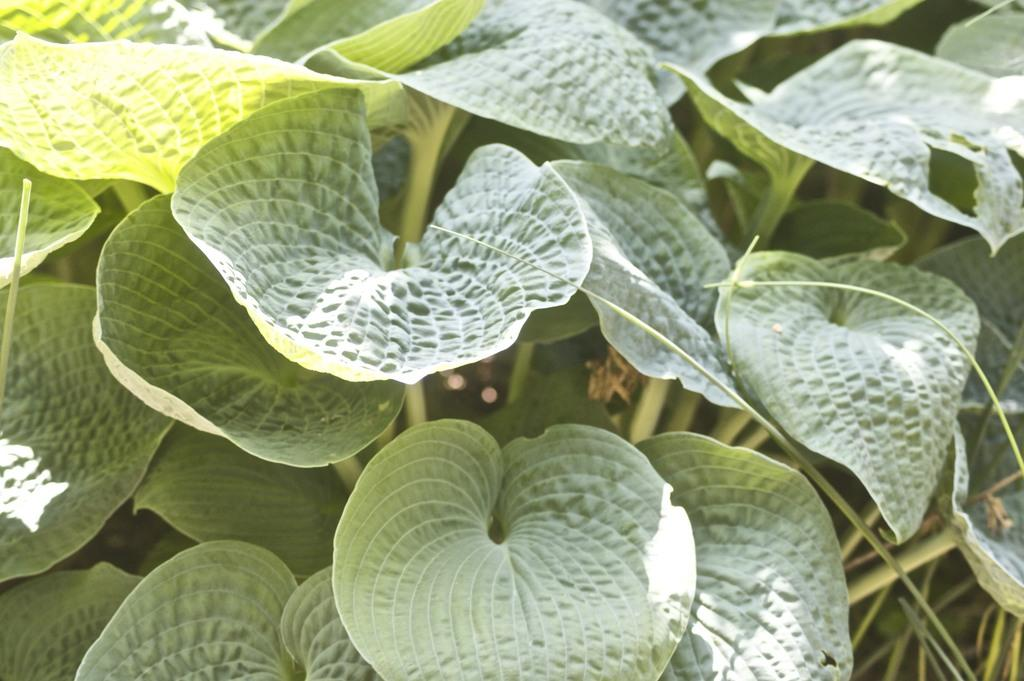What is the primary subject of the image? The primary subject of the image is many leaves. What can be observed about the color of the leaves? The leaves are green in color. What type of ink is used to draw the pear in the image? There is no pear present in the image, and therefore no ink or drawing can be observed. 